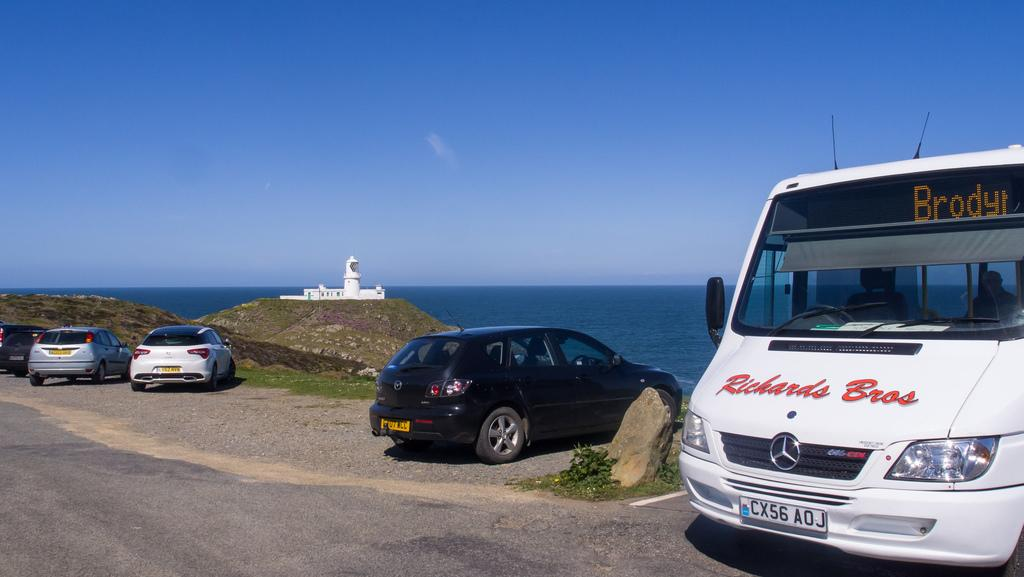What can be seen in the image? There are vehicles in the image. What is visible in the background of the image? There is a white building and water visible in the background of the image. What is the color of the sky in the image? The sky is blue in color. What type of tax is being discussed in the image? There is no discussion of tax in the image; it features vehicles, a building, water, and a blue sky. 